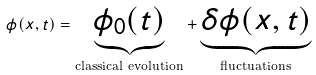<formula> <loc_0><loc_0><loc_500><loc_500>\phi ( x , t ) = \underbrace { \phi _ { 0 } ( t ) } _ { \text {classical evolution} } + \underbrace { \delta \phi ( x , t ) } _ { \text {fluctuations} }</formula> 